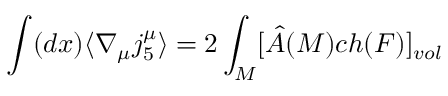Convert formula to latex. <formula><loc_0><loc_0><loc_500><loc_500>\int ( d x ) \langle \nabla _ { \mu } j _ { 5 } ^ { \mu } \rangle = 2 \int _ { M } [ \hat { A } ( M ) c h ( F ) ] _ { v o l }</formula> 